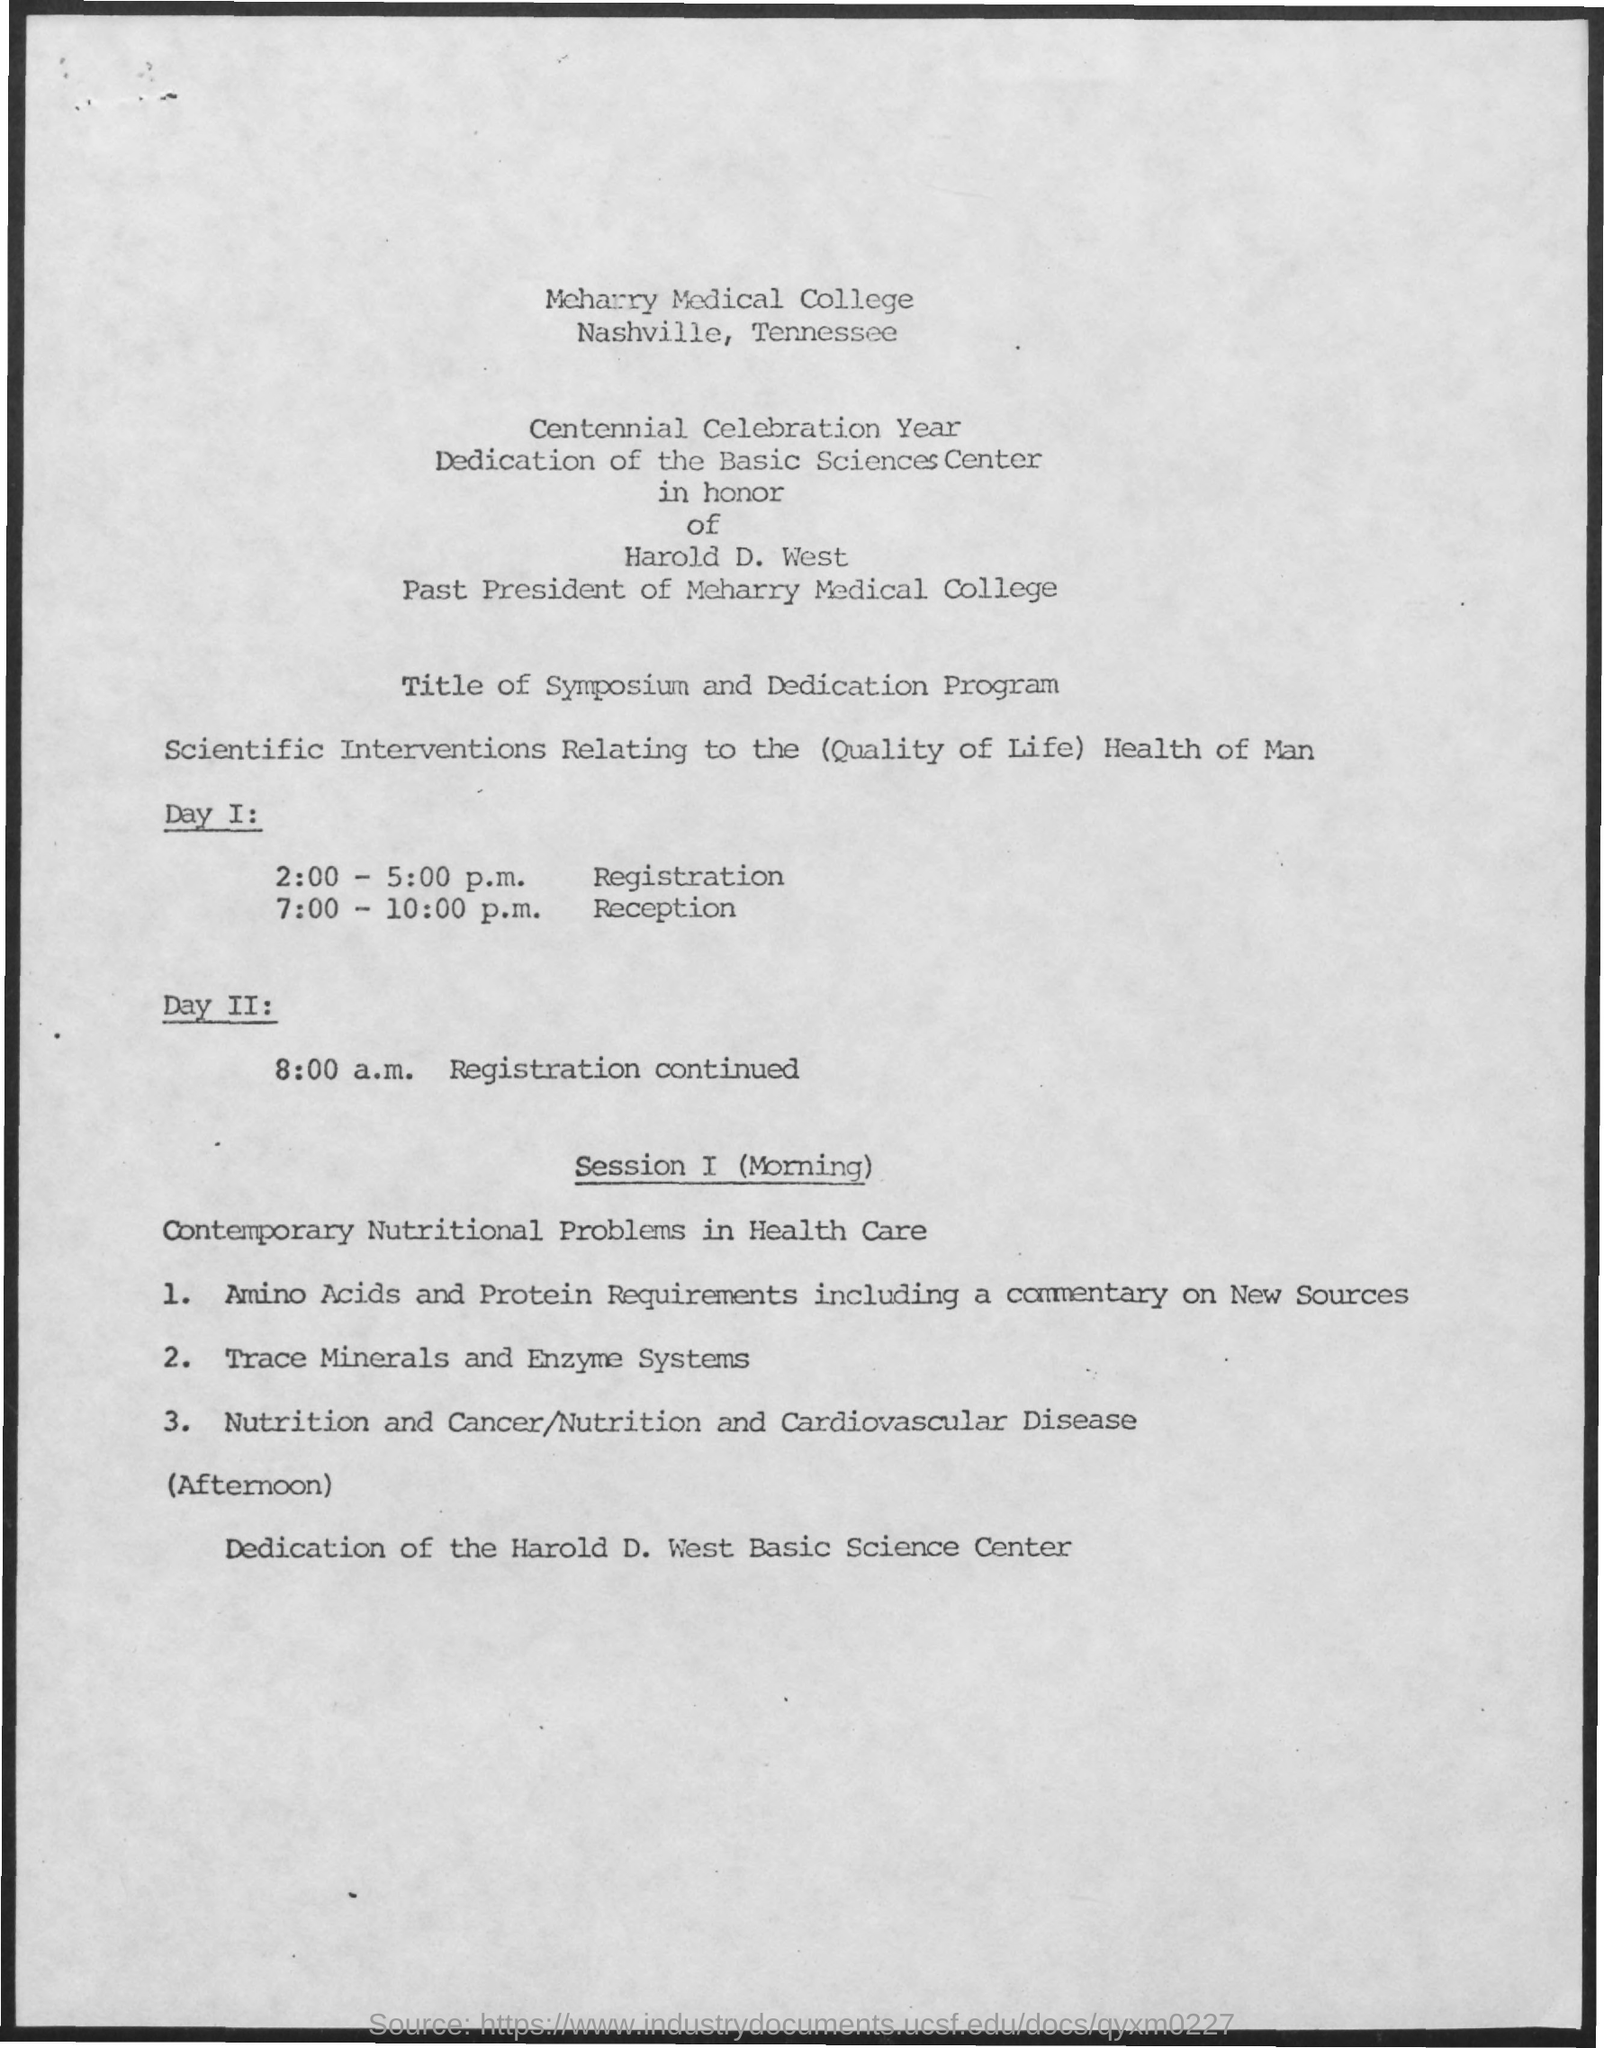What is the schedule at the time of 2:00 - 5:00 p.m. on day 1 ?
Offer a terse response. Registration. What is the schedule at the time of 7:00- 10:00 p.m. on day 1?
Keep it short and to the point. Reception. What is the schedule at the time of 8:00 a.m. on day 2 ?
Make the answer very short. Registration continued. 